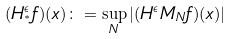<formula> <loc_0><loc_0><loc_500><loc_500>( H ^ { \epsilon } _ { ^ { * } } f ) ( x ) \colon = \sup _ { N } | ( H ^ { \epsilon } M _ { N } f ) ( x ) |</formula> 